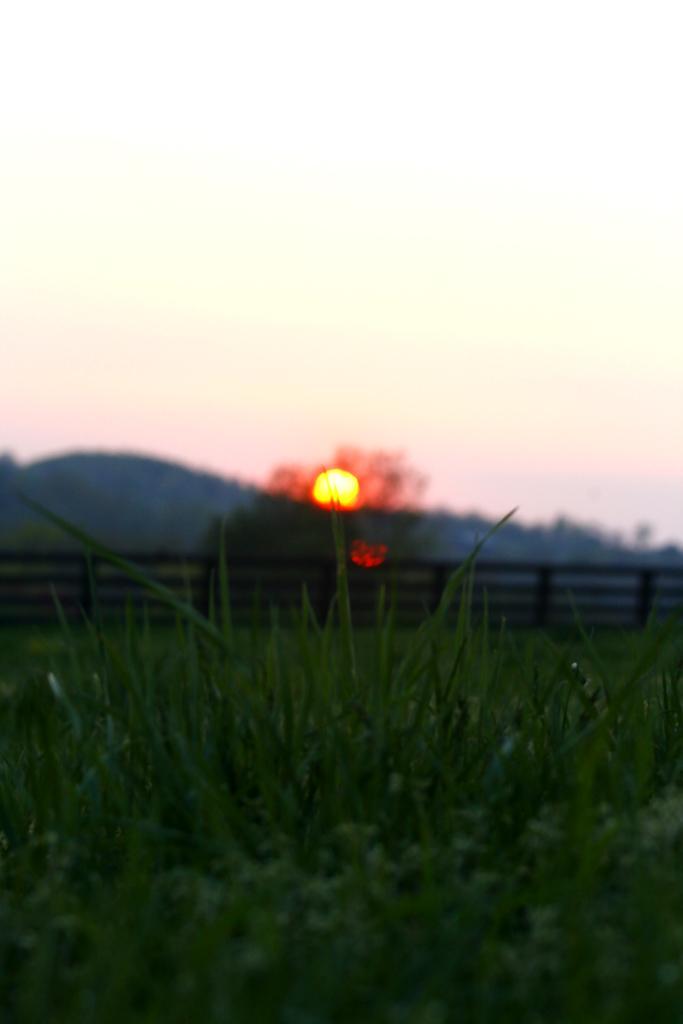Can you describe this image briefly? In this picture we can observe green color grass on the ground. There is a railing. In the background we can observe a hill, sky and a sun. 